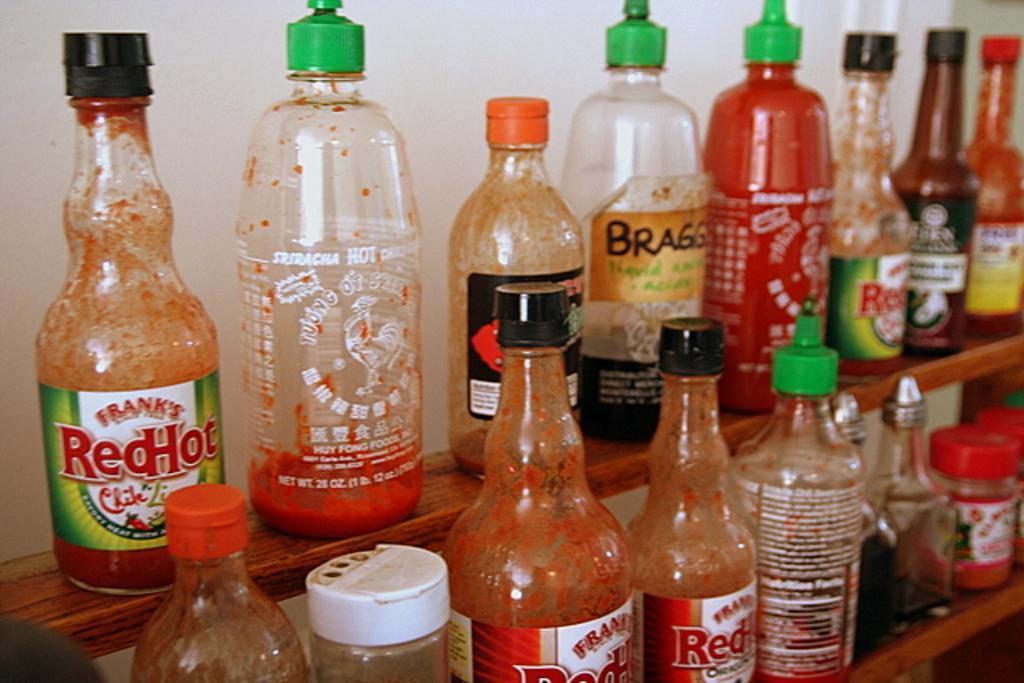In one or two sentences, can you explain what this image depicts? There are group of bottles placed on a wooden stand. 